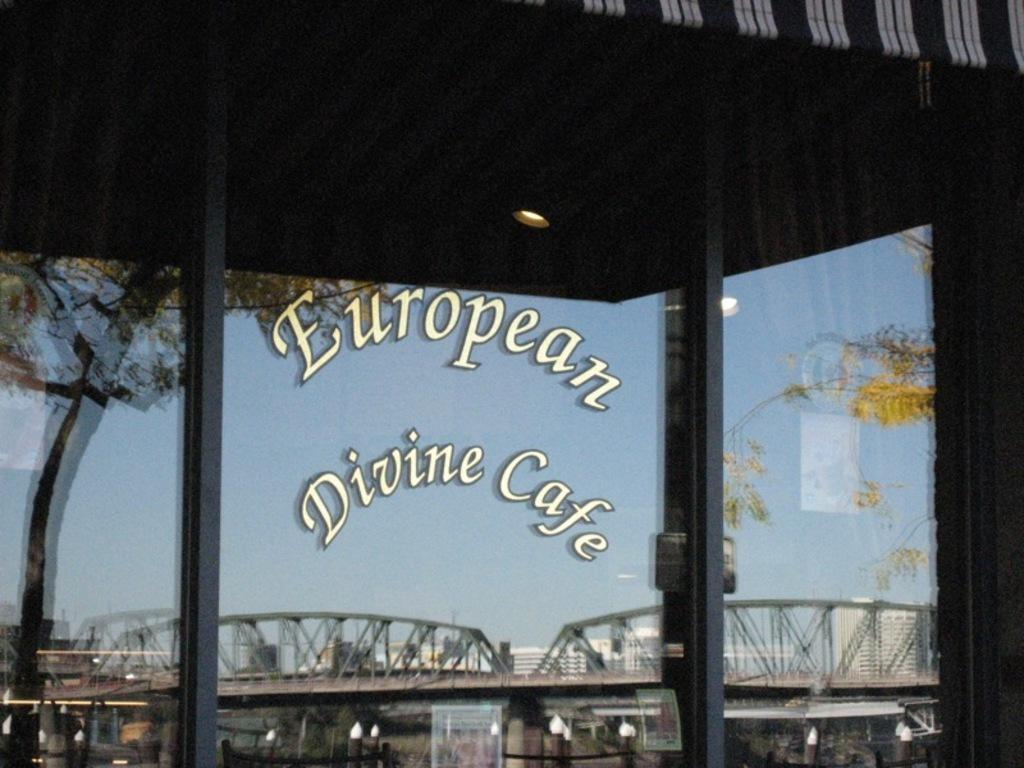What type of structure can be seen in the image? There is a bridge in the image. What other objects are present in the image? There are two poles, a light, and a shed in the image. What type of vegetation is visible in the image? There are trees in the image. What can be seen in the background of the image? There are buildings and the sky visible in the background of the image. What type of brass instrument is being played by the fish in the image? There are no fish or brass instruments present in the image. 